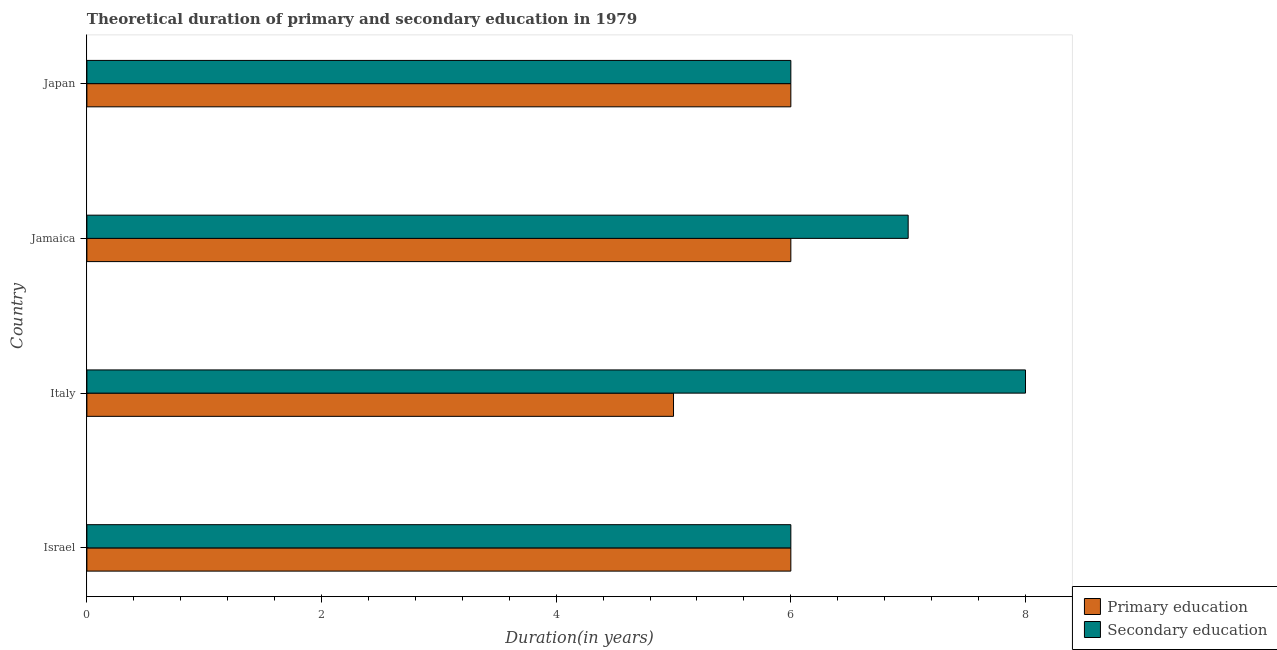How many groups of bars are there?
Make the answer very short. 4. Are the number of bars per tick equal to the number of legend labels?
Your answer should be very brief. Yes. Are the number of bars on each tick of the Y-axis equal?
Your answer should be compact. Yes. How many bars are there on the 1st tick from the top?
Keep it short and to the point. 2. Across all countries, what is the maximum duration of secondary education?
Your response must be concise. 8. In which country was the duration of primary education minimum?
Your answer should be compact. Italy. What is the total duration of secondary education in the graph?
Make the answer very short. 27. What is the difference between the duration of primary education in Italy and that in Jamaica?
Make the answer very short. -1. What is the difference between the duration of secondary education in Japan and the duration of primary education in Italy?
Provide a short and direct response. 1. What is the average duration of secondary education per country?
Provide a short and direct response. 6.75. What is the difference between the duration of secondary education and duration of primary education in Jamaica?
Offer a very short reply. 1. What is the ratio of the duration of secondary education in Israel to that in Japan?
Your answer should be compact. 1. What is the difference between the highest and the lowest duration of secondary education?
Ensure brevity in your answer.  2. In how many countries, is the duration of primary education greater than the average duration of primary education taken over all countries?
Your answer should be compact. 3. Is the sum of the duration of secondary education in Israel and Japan greater than the maximum duration of primary education across all countries?
Your response must be concise. Yes. What does the 1st bar from the bottom in Japan represents?
Your answer should be compact. Primary education. How many bars are there?
Make the answer very short. 8. How many countries are there in the graph?
Your answer should be compact. 4. What is the difference between two consecutive major ticks on the X-axis?
Keep it short and to the point. 2. How are the legend labels stacked?
Make the answer very short. Vertical. What is the title of the graph?
Give a very brief answer. Theoretical duration of primary and secondary education in 1979. Does "Merchandise imports" appear as one of the legend labels in the graph?
Provide a short and direct response. No. What is the label or title of the X-axis?
Your response must be concise. Duration(in years). What is the Duration(in years) of Primary education in Italy?
Your answer should be very brief. 5. What is the Duration(in years) of Secondary education in Jamaica?
Offer a very short reply. 7. What is the Duration(in years) in Primary education in Japan?
Ensure brevity in your answer.  6. What is the Duration(in years) of Secondary education in Japan?
Offer a very short reply. 6. What is the total Duration(in years) in Primary education in the graph?
Provide a short and direct response. 23. What is the difference between the Duration(in years) in Primary education in Israel and that in Japan?
Provide a short and direct response. 0. What is the difference between the Duration(in years) in Secondary education in Israel and that in Japan?
Offer a terse response. 0. What is the difference between the Duration(in years) of Primary education in Italy and that in Japan?
Your answer should be compact. -1. What is the difference between the Duration(in years) of Primary education in Israel and the Duration(in years) of Secondary education in Jamaica?
Keep it short and to the point. -1. What is the difference between the Duration(in years) in Primary education in Italy and the Duration(in years) in Secondary education in Jamaica?
Your answer should be very brief. -2. What is the difference between the Duration(in years) of Primary education in Italy and the Duration(in years) of Secondary education in Japan?
Your response must be concise. -1. What is the difference between the Duration(in years) of Primary education in Jamaica and the Duration(in years) of Secondary education in Japan?
Provide a short and direct response. 0. What is the average Duration(in years) in Primary education per country?
Provide a succinct answer. 5.75. What is the average Duration(in years) in Secondary education per country?
Give a very brief answer. 6.75. What is the difference between the Duration(in years) of Primary education and Duration(in years) of Secondary education in Italy?
Provide a short and direct response. -3. What is the difference between the Duration(in years) of Primary education and Duration(in years) of Secondary education in Jamaica?
Offer a very short reply. -1. What is the difference between the Duration(in years) in Primary education and Duration(in years) in Secondary education in Japan?
Make the answer very short. 0. What is the ratio of the Duration(in years) in Primary education in Israel to that in Italy?
Your answer should be very brief. 1.2. What is the ratio of the Duration(in years) of Secondary education in Israel to that in Italy?
Provide a succinct answer. 0.75. What is the ratio of the Duration(in years) of Primary education in Israel to that in Jamaica?
Provide a short and direct response. 1. What is the ratio of the Duration(in years) in Secondary education in Israel to that in Jamaica?
Give a very brief answer. 0.86. What is the ratio of the Duration(in years) in Primary education in Israel to that in Japan?
Your answer should be compact. 1. What is the ratio of the Duration(in years) in Secondary education in Israel to that in Japan?
Provide a succinct answer. 1. What is the ratio of the Duration(in years) in Secondary education in Italy to that in Jamaica?
Your response must be concise. 1.14. What is the ratio of the Duration(in years) in Primary education in Italy to that in Japan?
Offer a very short reply. 0.83. What is the ratio of the Duration(in years) in Secondary education in Italy to that in Japan?
Offer a terse response. 1.33. What is the ratio of the Duration(in years) of Primary education in Jamaica to that in Japan?
Your answer should be compact. 1. What is the ratio of the Duration(in years) in Secondary education in Jamaica to that in Japan?
Provide a succinct answer. 1.17. What is the difference between the highest and the lowest Duration(in years) of Secondary education?
Provide a succinct answer. 2. 